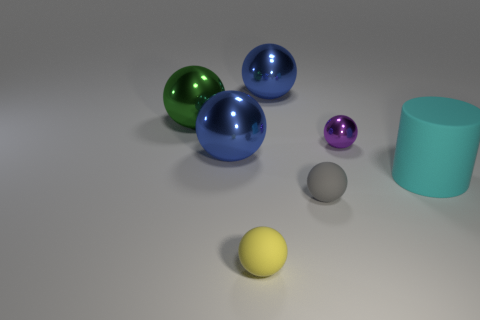Subtract 3 spheres. How many spheres are left? 3 Subtract all blue balls. How many balls are left? 4 Subtract all large green balls. How many balls are left? 5 Subtract all cyan spheres. Subtract all purple blocks. How many spheres are left? 6 Add 1 gray matte things. How many objects exist? 8 Subtract all balls. How many objects are left? 1 Add 1 green shiny balls. How many green shiny balls exist? 2 Subtract 1 cyan cylinders. How many objects are left? 6 Subtract all large blue metal things. Subtract all matte objects. How many objects are left? 2 Add 6 big blue spheres. How many big blue spheres are left? 8 